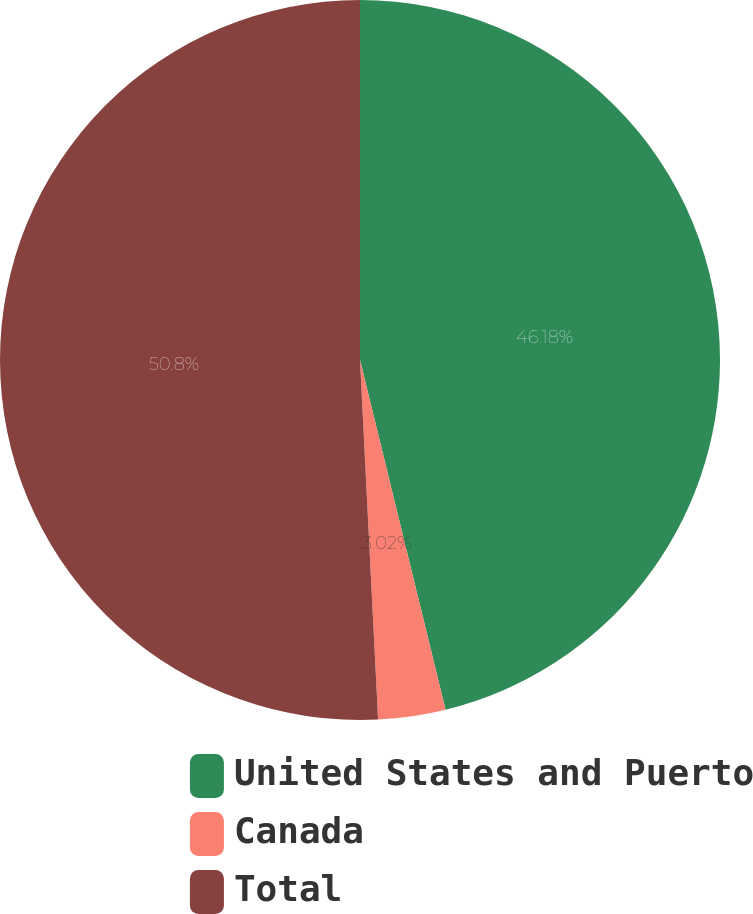<chart> <loc_0><loc_0><loc_500><loc_500><pie_chart><fcel>United States and Puerto<fcel>Canada<fcel>Total<nl><fcel>46.18%<fcel>3.02%<fcel>50.8%<nl></chart> 